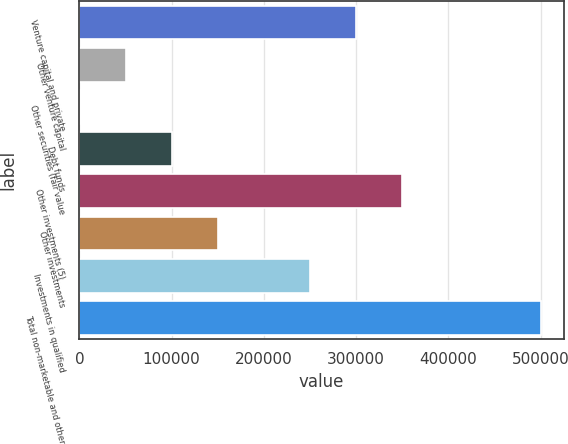<chart> <loc_0><loc_0><loc_500><loc_500><bar_chart><fcel>Venture capital and private<fcel>Other venture capital<fcel>Other securities (fair value<fcel>Debt funds<fcel>Other investments (5)<fcel>Other investments<fcel>Investments in qualified<fcel>Total non-marketable and other<nl><fcel>300137<fcel>50137.9<fcel>138<fcel>100138<fcel>350137<fcel>150138<fcel>250138<fcel>500137<nl></chart> 